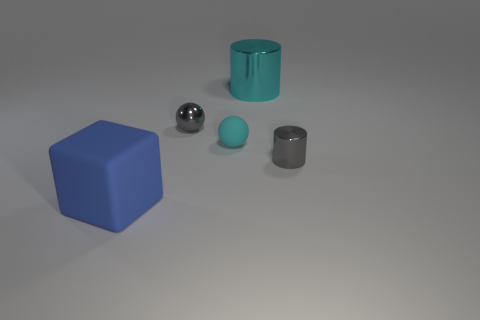There is a gray thing that is the same size as the gray sphere; what is its shape?
Your answer should be very brief. Cylinder. What shape is the thing that is the same color as the small shiny cylinder?
Provide a succinct answer. Sphere. Is the number of matte objects in front of the big rubber object the same as the number of green rubber balls?
Offer a terse response. Yes. There is a cyan thing that is on the left side of the large object that is behind the small gray metallic object that is behind the small metal cylinder; what is its material?
Provide a short and direct response. Rubber. There is a tiny cyan thing that is the same material as the blue object; what shape is it?
Ensure brevity in your answer.  Sphere. Are there any other things that are the same color as the block?
Your response must be concise. No. There is a blue cube on the left side of the cyan object to the left of the large cyan object; how many blue cubes are on the right side of it?
Offer a terse response. 0. What number of cyan objects are big metallic cylinders or tiny shiny cylinders?
Provide a short and direct response. 1. There is a gray cylinder; does it have the same size as the blue rubber thing in front of the big cyan cylinder?
Give a very brief answer. No. There is another tiny thing that is the same shape as the cyan metallic object; what is its material?
Your answer should be compact. Metal. 